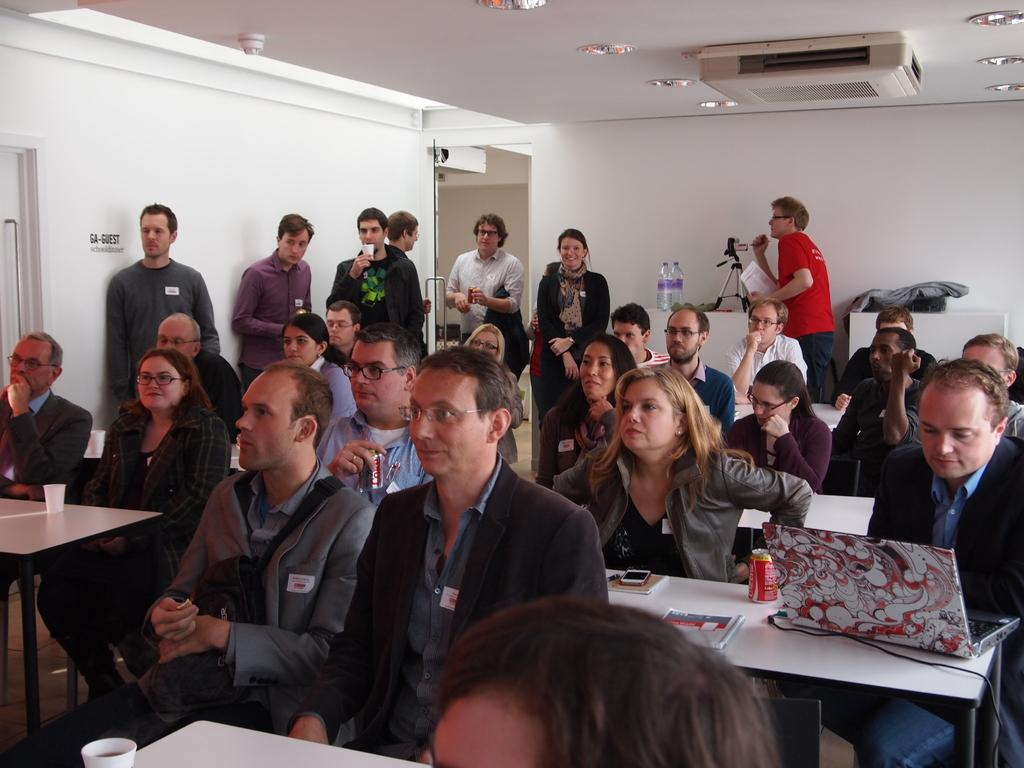What are the people in the image doing? The people in the image are standing on chairs. What direction are the people looking? The people are looking to the left. Are there any other people visible in the image? Yes, there are other people standing behind the group on chairs. What type of queen can be seen in the image? There is no queen present in the image; it features a group of people standing on chairs and looking to the left. Can you tell me how many railway tracks are visible in the image? There are no railway tracks visible in the image. 